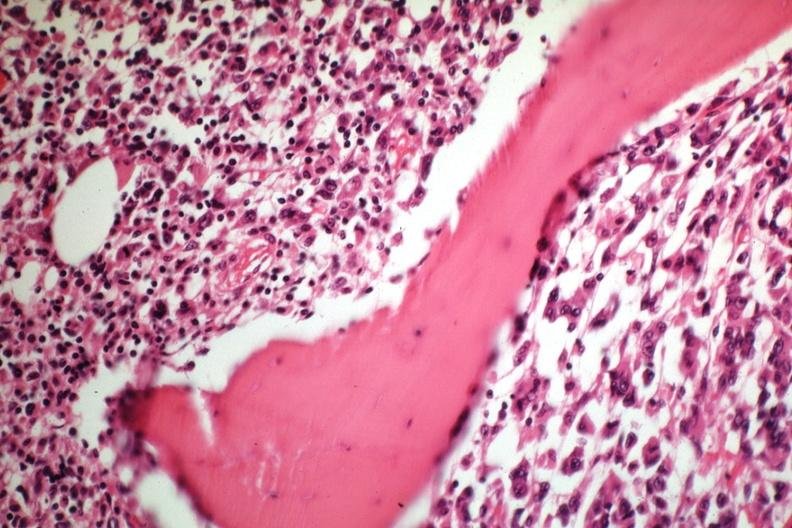s joints present?
Answer the question using a single word or phrase. Yes 